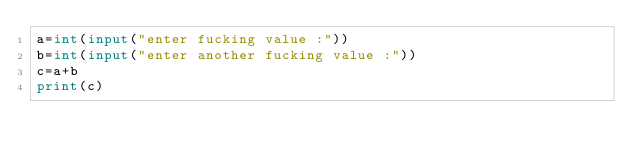Convert code to text. <code><loc_0><loc_0><loc_500><loc_500><_Python_>a=int(input("enter fucking value :"))
b=int(input("enter another fucking value :"))
c=a+b
print(c)
</code> 